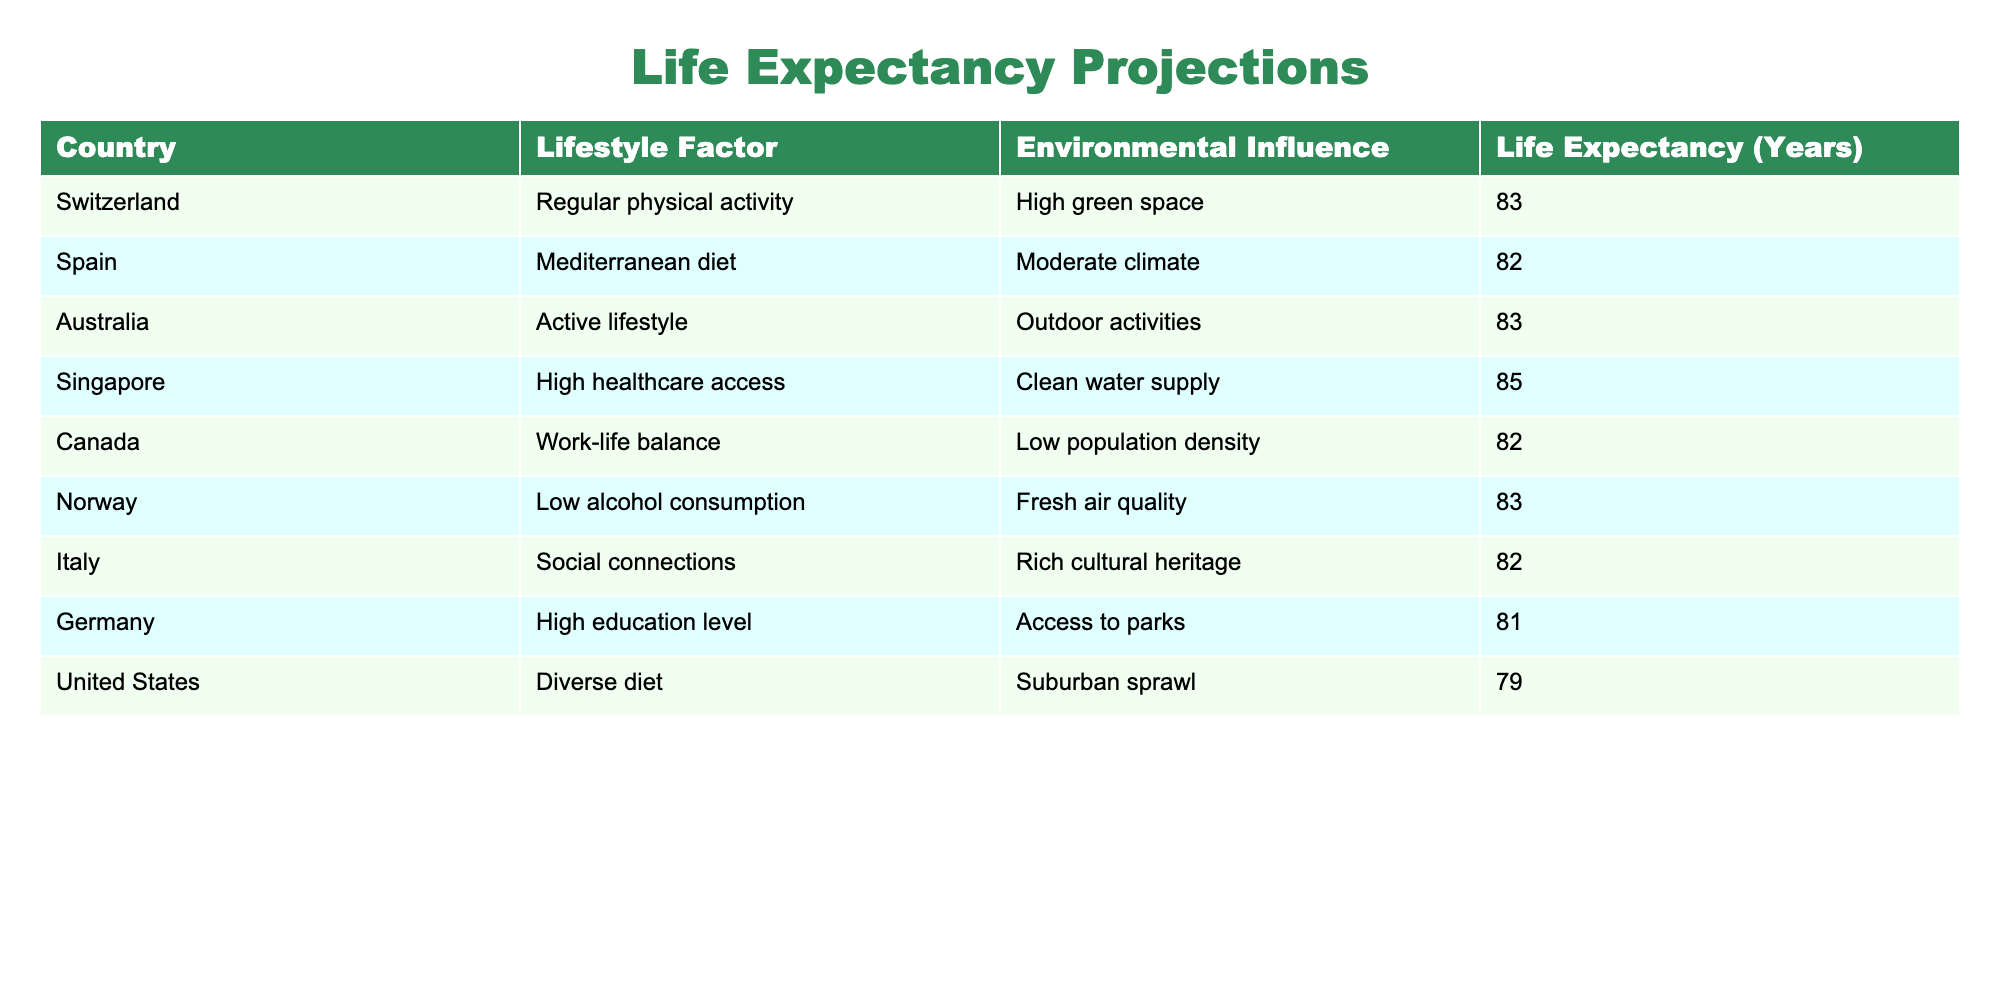What is the life expectancy in Singapore? The life expectancy in Singapore is given directly in the table under the "Life Expectancy (Years)" column for Singapore. It shows a value of 85 years.
Answer: 85 Which country has the highest life expectancy and what is it? By comparing the "Life Expectancy (Years)" values across the countries listed in the table, Singapore has the highest life expectancy at 85 years.
Answer: Singapore, 85 What is the average life expectancy of countries with high healthcare access? There is one country with high healthcare access listed in the table, which is Singapore with a life expectancy of 85. Since there's only one data point, the average is also 85.
Answer: 85 Is the life expectancy equal for both Italy and Spain? Italy has a life expectancy of 82 years, while Spain also has a life expectancy of 82 years. Therefore, their life expectancies are equal.
Answer: Yes How many years more can one expect to live in Switzerland compared to the United States? Switzerland's life expectancy is 83 years, and the United States' is 79 years. The difference is calculated as 83 - 79 = 4 years.
Answer: 4 years What lifestyle factor is associated with the lowest life expectancy among the listed countries? By reviewing the lifestyle factors across the table and corresponding life expectancies, the United States has a diverse diet with the lowest life expectancy of 79 years, which indicates that this is the factor associated with that life expectancy.
Answer: Diverse diet Combine the life expectancies of Norway, Canada, and Germany. What is the total? Norway has a life expectancy of 83, Canada has 82, and Germany has 81. Summing these values gives 83 + 82 + 81 = 246.
Answer: 246 Which country would likely have better life expectancy: one that is predominantly urban or one with a high green space? The table shows Switzerland with high green space and a life expectancy of 83, while countries like the United States with suburban sprawl have a lower life expectancy of 79. Based on this evidence, one with high green space likely has better life expectancy.
Answer: Yes How much higher is the life expectancy in Australia compared to Germany? Australia has a life expectancy of 83 years and Germany has 81 years, showing a difference of 83 - 81 = 2 years higher in Australia.
Answer: 2 years 